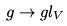Convert formula to latex. <formula><loc_0><loc_0><loc_500><loc_500>g \rightarrow g l _ { V }</formula> 